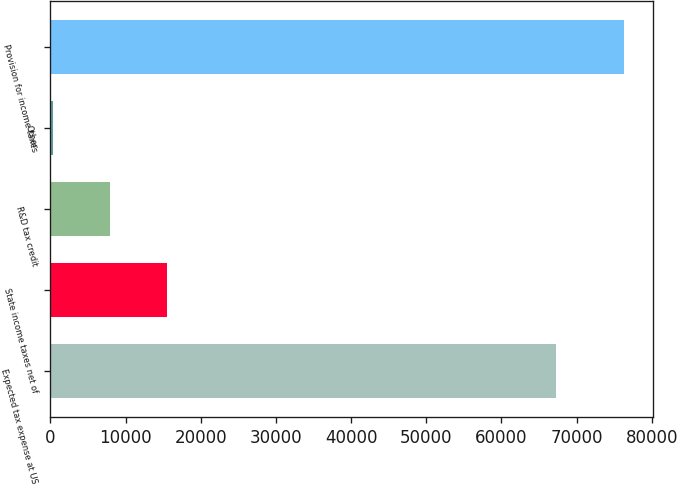Convert chart. <chart><loc_0><loc_0><loc_500><loc_500><bar_chart><fcel>Expected tax expense at US<fcel>State income taxes net of<fcel>R&D tax credit<fcel>Other<fcel>Provision for income taxes<nl><fcel>67267<fcel>15531.2<fcel>7931.1<fcel>331<fcel>76332<nl></chart> 